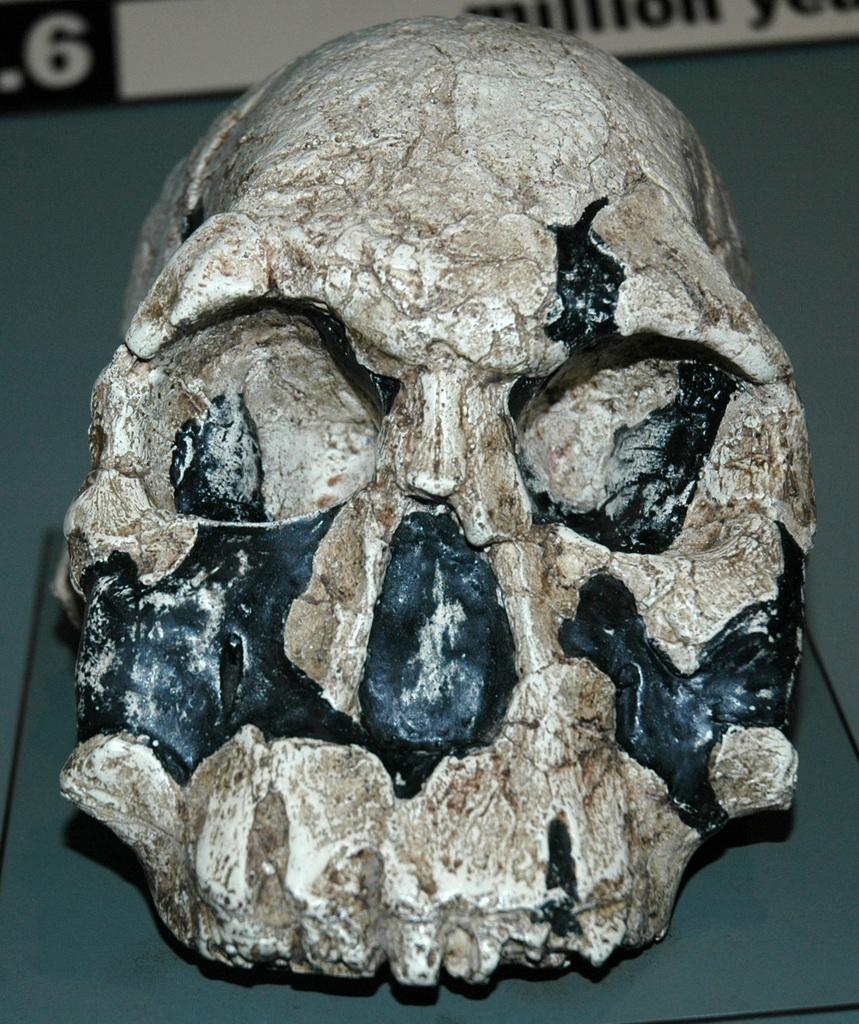What is placed on the floor in the image? There is a skull on the floor in the image. What else can be seen in the image besides the skull? There is a board in the image. Can you describe the setting where the image might have been taken? The image may have been taken in a hall. What type of noise can be heard coming from the throat of the ant in the image? There is no ant present in the image, and therefore no noise can be heard coming from its throat. 